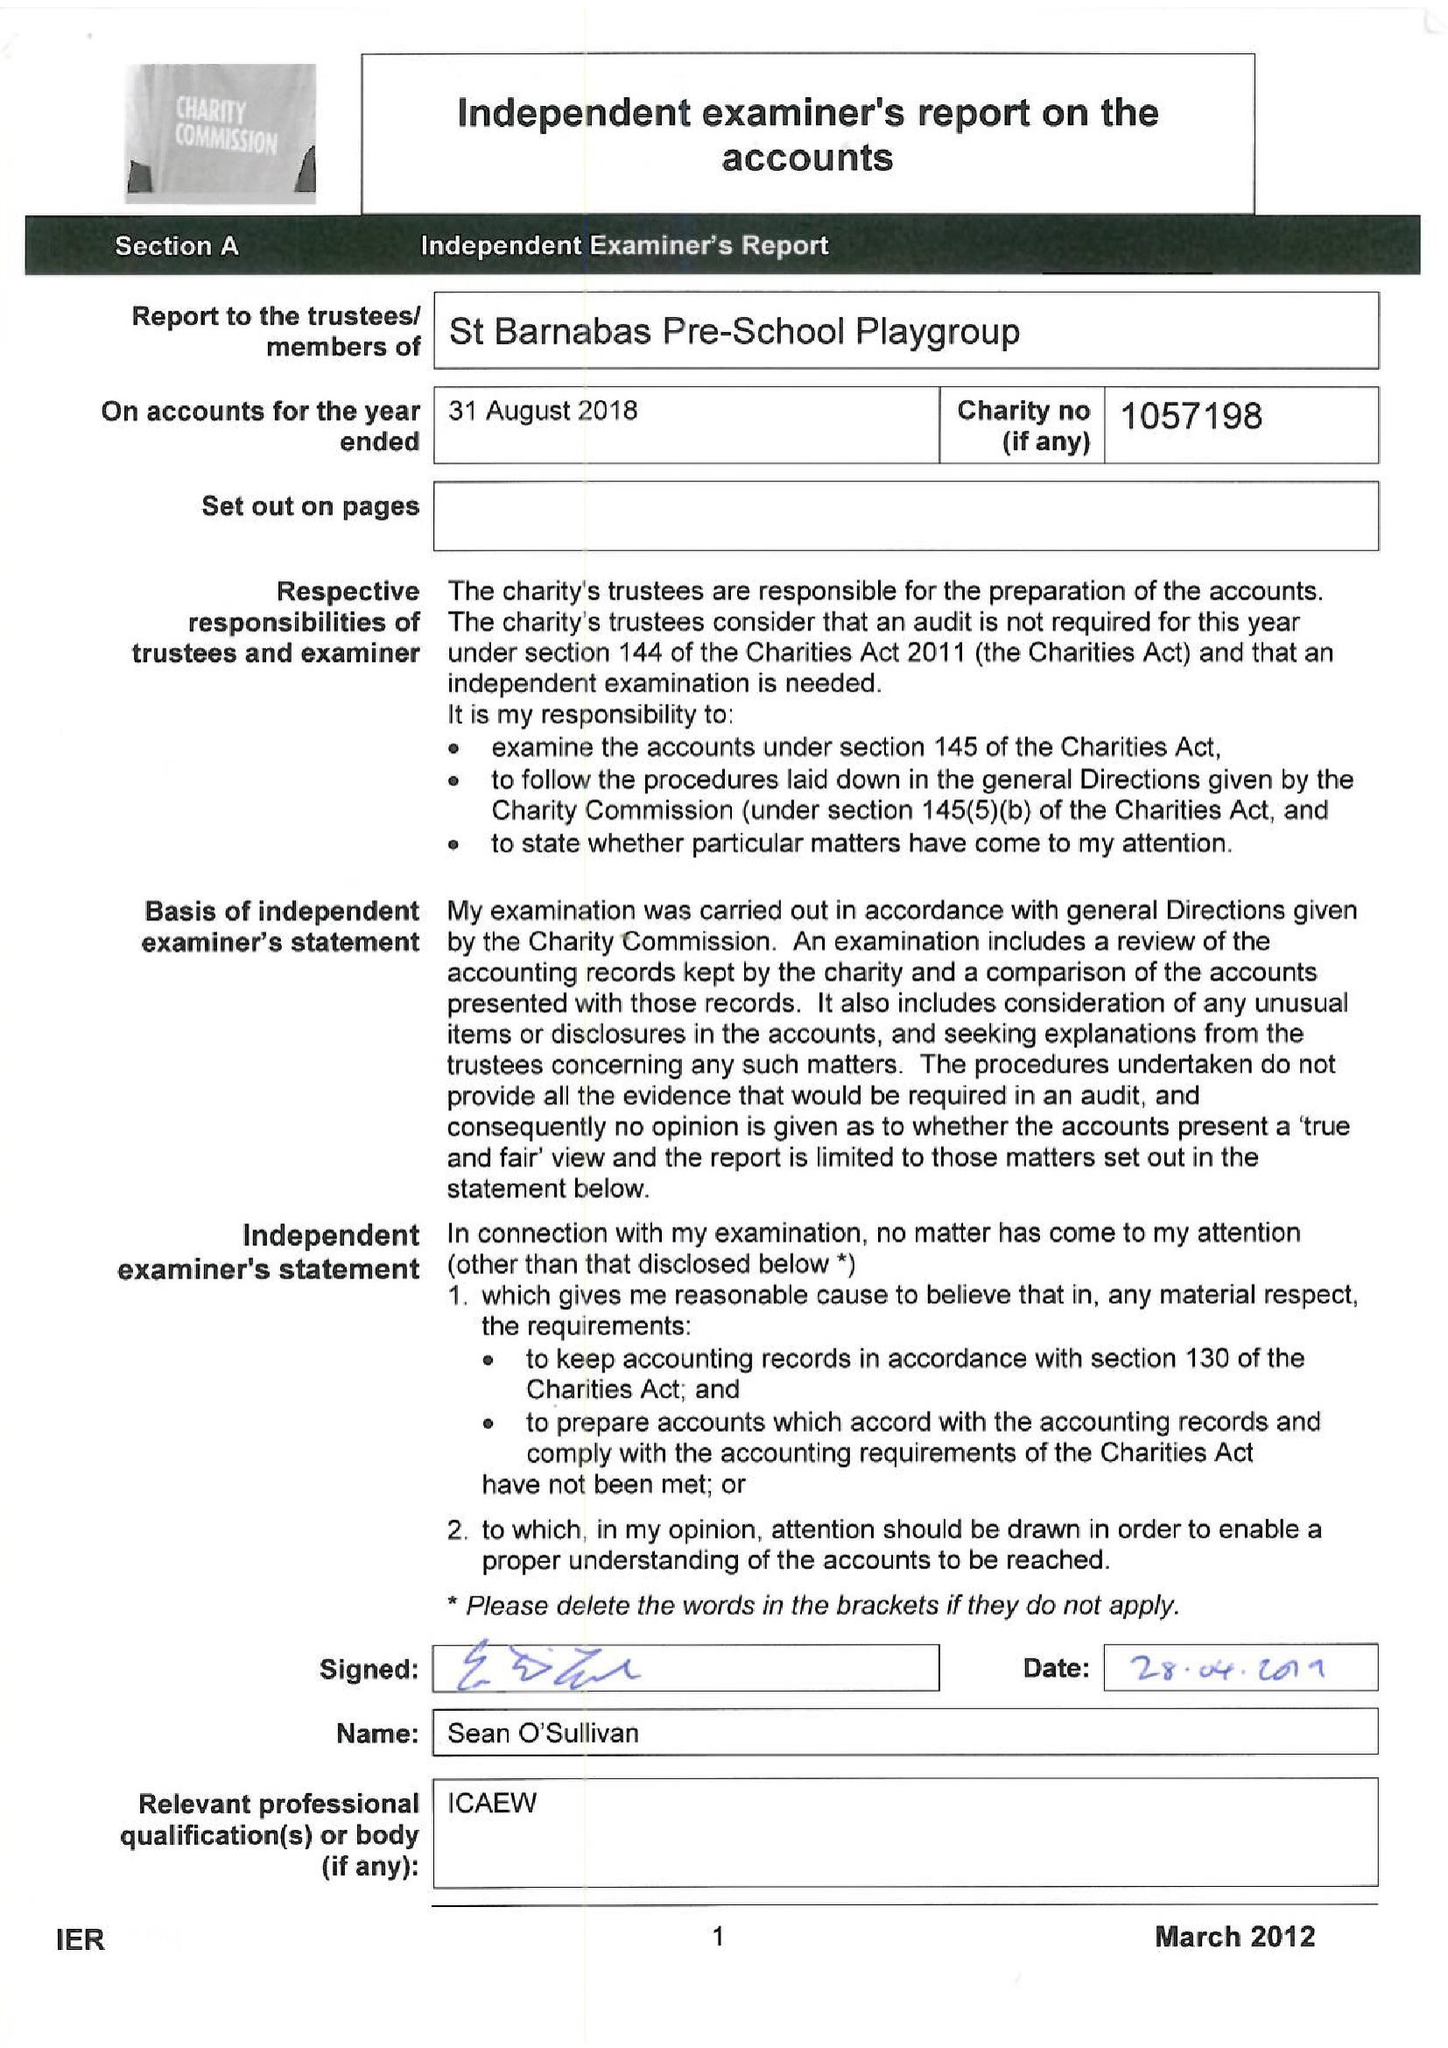What is the value for the address__post_town?
Answer the question using a single word or phrase. LONDON 